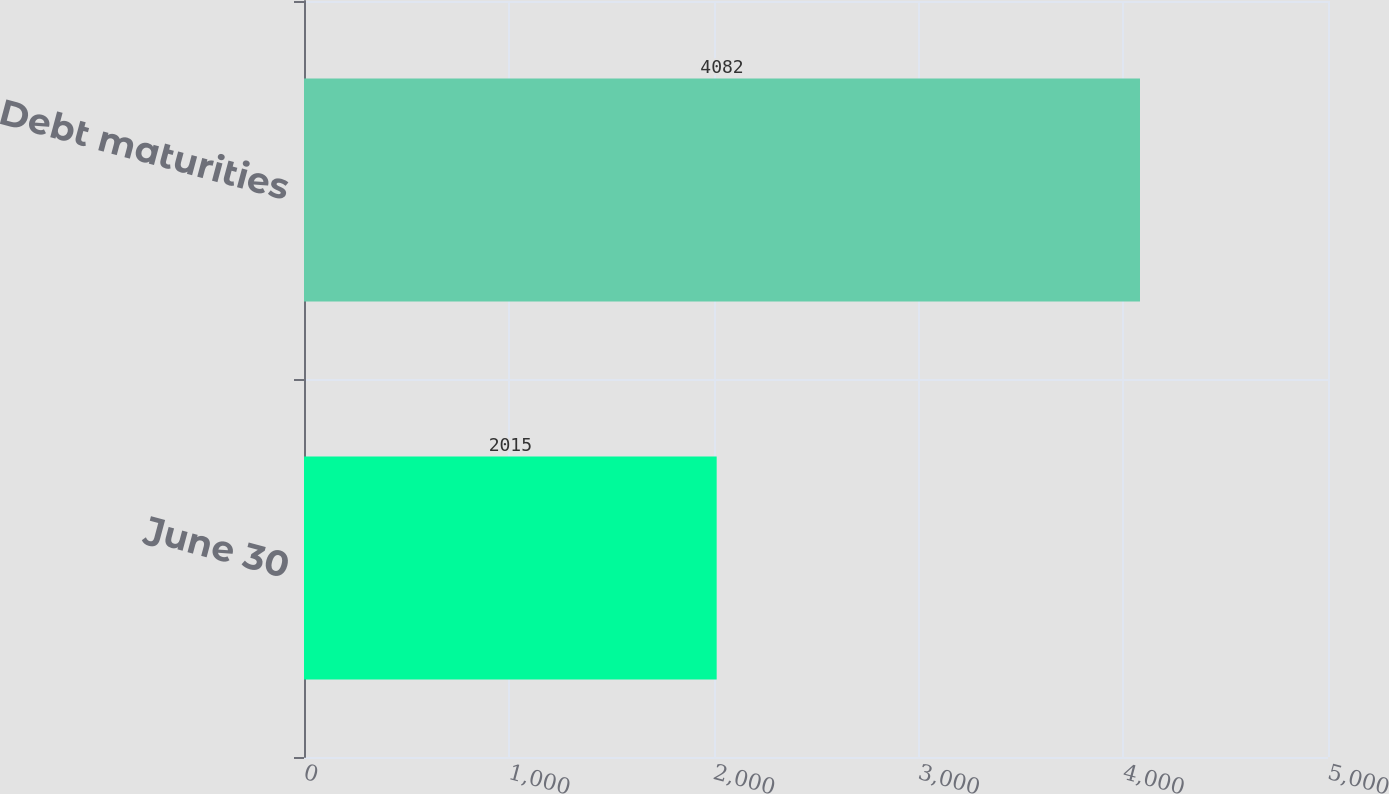Convert chart. <chart><loc_0><loc_0><loc_500><loc_500><bar_chart><fcel>June 30<fcel>Debt maturities<nl><fcel>2015<fcel>4082<nl></chart> 